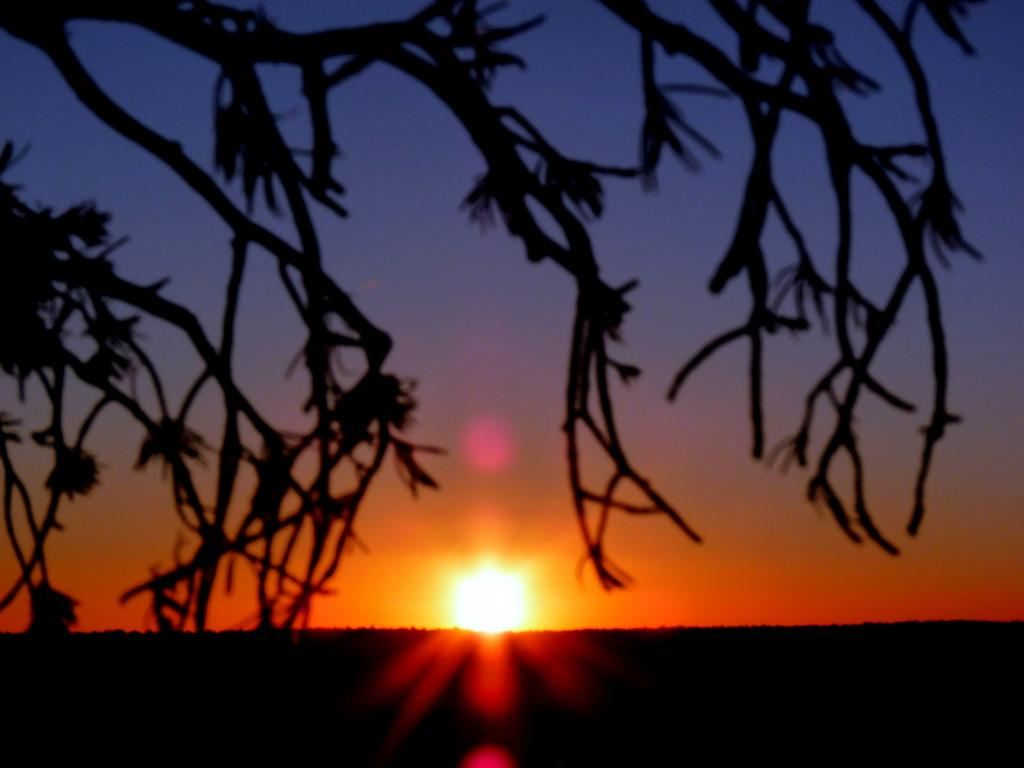What type of vegetation can be seen in the image? There are branches of a tree in the image. What is visible in the sky in the background of the image? The sun is visible in the sky in the background of the image. What type of question is being asked in the image? There is no question present in the image; it features branches of a tree and the sun in the sky. 